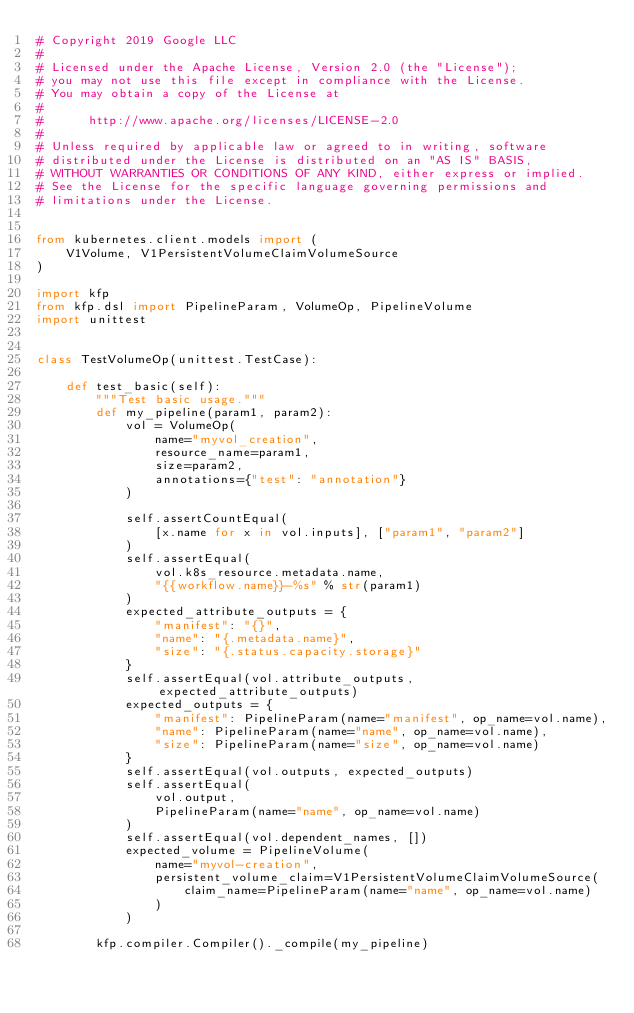<code> <loc_0><loc_0><loc_500><loc_500><_Python_># Copyright 2019 Google LLC
#
# Licensed under the Apache License, Version 2.0 (the "License");
# you may not use this file except in compliance with the License.
# You may obtain a copy of the License at
#
#      http://www.apache.org/licenses/LICENSE-2.0
#
# Unless required by applicable law or agreed to in writing, software
# distributed under the License is distributed on an "AS IS" BASIS,
# WITHOUT WARRANTIES OR CONDITIONS OF ANY KIND, either express or implied.
# See the License for the specific language governing permissions and
# limitations under the License.


from kubernetes.client.models import (
    V1Volume, V1PersistentVolumeClaimVolumeSource
)

import kfp
from kfp.dsl import PipelineParam, VolumeOp, PipelineVolume
import unittest


class TestVolumeOp(unittest.TestCase):

    def test_basic(self):
        """Test basic usage."""
        def my_pipeline(param1, param2):
            vol = VolumeOp(
                name="myvol_creation",
                resource_name=param1,
                size=param2,
                annotations={"test": "annotation"}
            )

            self.assertCountEqual(
                [x.name for x in vol.inputs], ["param1", "param2"]
            )
            self.assertEqual(
                vol.k8s_resource.metadata.name,
                "{{workflow.name}}-%s" % str(param1)
            )
            expected_attribute_outputs = {
                "manifest": "{}",
                "name": "{.metadata.name}",
                "size": "{.status.capacity.storage}"
            }
            self.assertEqual(vol.attribute_outputs, expected_attribute_outputs)
            expected_outputs = {
                "manifest": PipelineParam(name="manifest", op_name=vol.name),
                "name": PipelineParam(name="name", op_name=vol.name),
                "size": PipelineParam(name="size", op_name=vol.name)
            }
            self.assertEqual(vol.outputs, expected_outputs)
            self.assertEqual(
                vol.output,
                PipelineParam(name="name", op_name=vol.name)
            )
            self.assertEqual(vol.dependent_names, [])
            expected_volume = PipelineVolume(
                name="myvol-creation",
                persistent_volume_claim=V1PersistentVolumeClaimVolumeSource(
                    claim_name=PipelineParam(name="name", op_name=vol.name)
                )
            )
        
        kfp.compiler.Compiler()._compile(my_pipeline)
</code> 